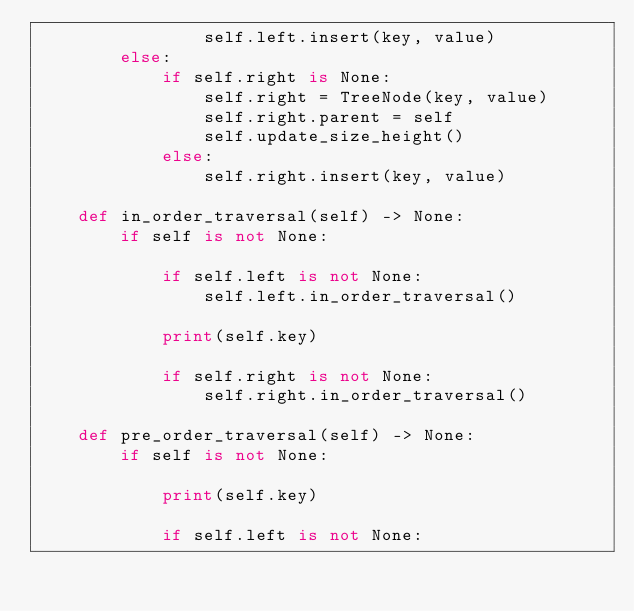<code> <loc_0><loc_0><loc_500><loc_500><_Python_>                self.left.insert(key, value)
        else:
            if self.right is None:
                self.right = TreeNode(key, value)
                self.right.parent = self
                self.update_size_height()
            else:
                self.right.insert(key, value)

    def in_order_traversal(self) -> None:
        if self is not None:

            if self.left is not None:
                self.left.in_order_traversal()

            print(self.key)

            if self.right is not None:
                self.right.in_order_traversal()

    def pre_order_traversal(self) -> None:
        if self is not None:

            print(self.key)

            if self.left is not None:</code> 